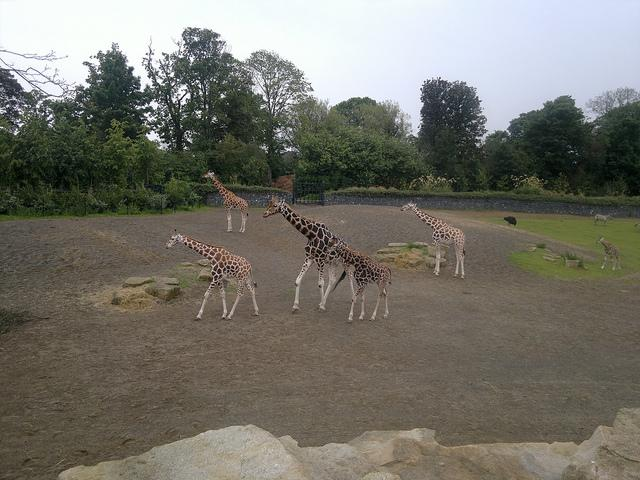What feature do the animals have? spots 